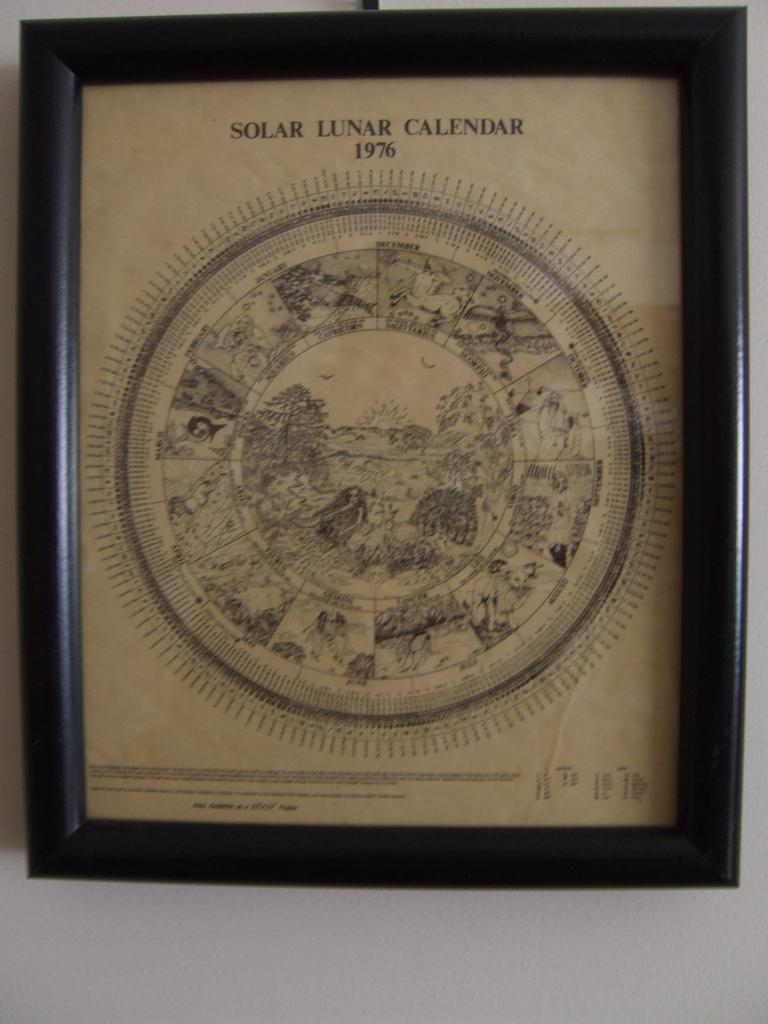Provide a one-sentence caption for the provided image. A framed image of the 1976 solar lunar calendar. 